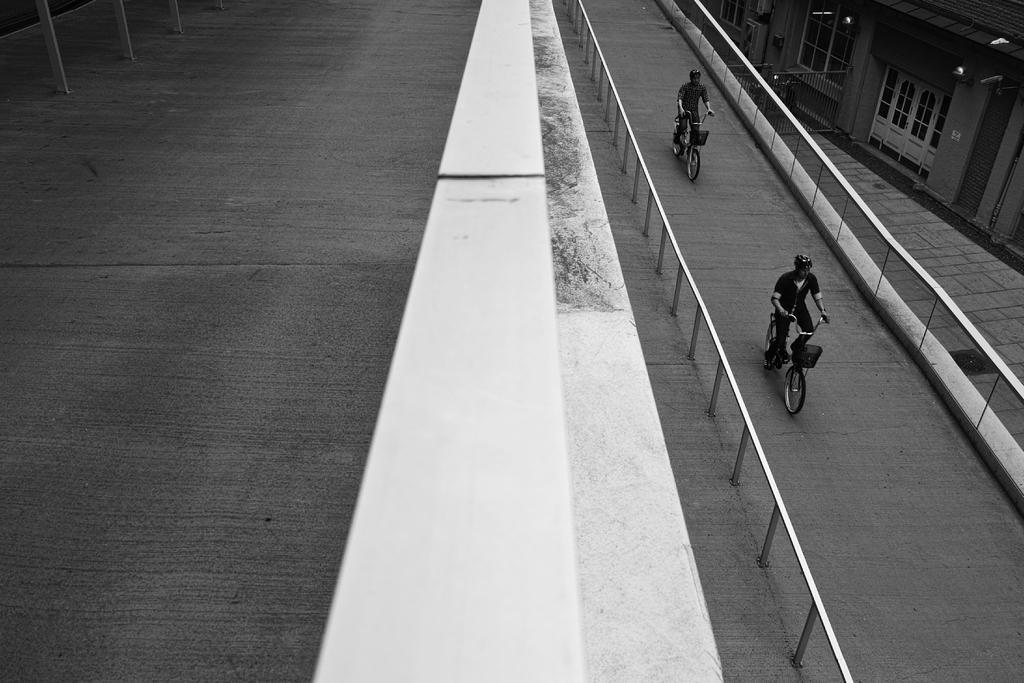Please provide a concise description of this image. This is a black and white picture. Here we can see two persons are riding bicycles. This is road and there is a fence. Here we can see a house. 